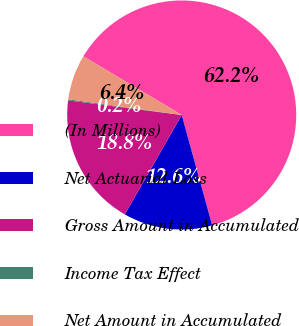Convert chart to OTSL. <chart><loc_0><loc_0><loc_500><loc_500><pie_chart><fcel>(In Millions)<fcel>Net Actuarial Loss<fcel>Gross Amount in Accumulated<fcel>Income Tax Effect<fcel>Net Amount in Accumulated<nl><fcel>62.15%<fcel>12.56%<fcel>18.76%<fcel>0.16%<fcel>6.36%<nl></chart> 